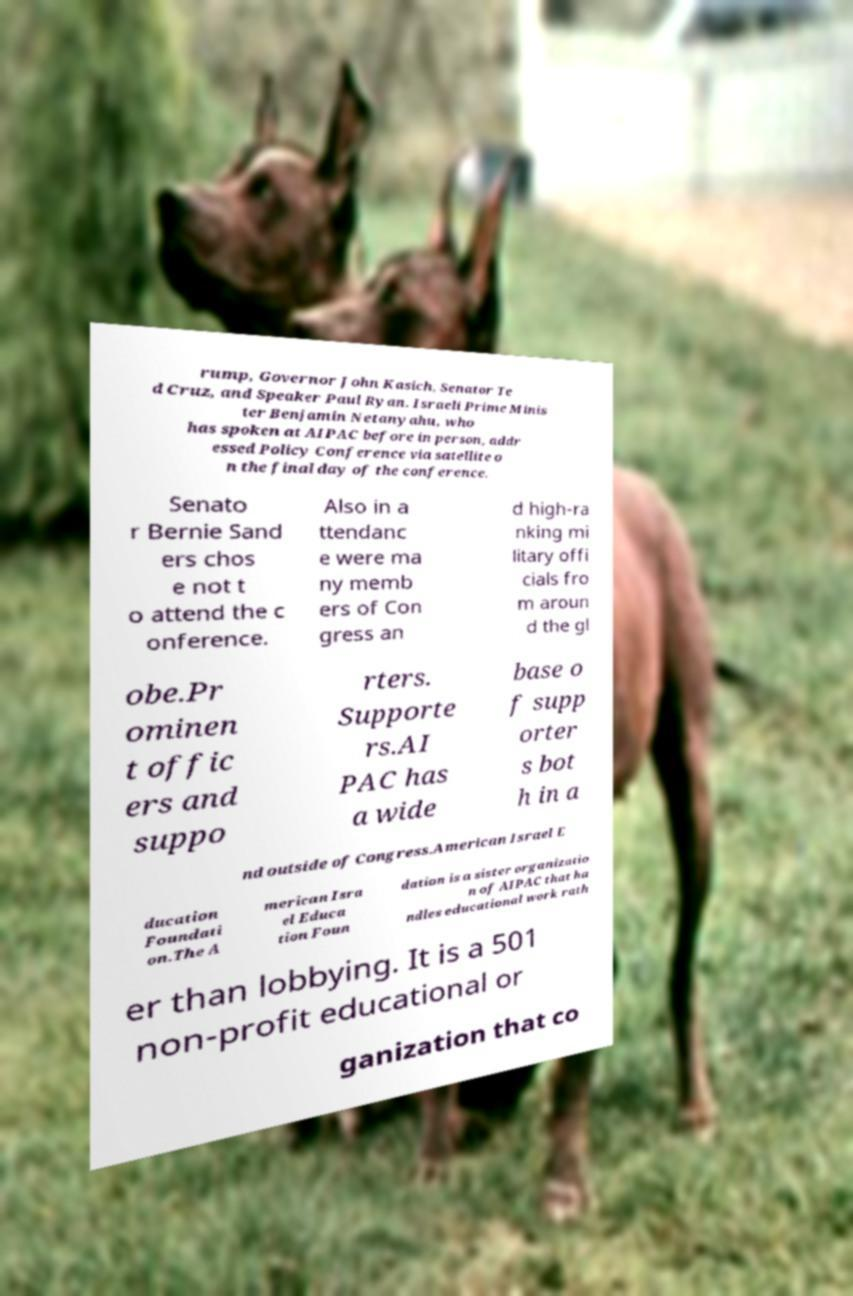I need the written content from this picture converted into text. Can you do that? rump, Governor John Kasich, Senator Te d Cruz, and Speaker Paul Ryan. Israeli Prime Minis ter Benjamin Netanyahu, who has spoken at AIPAC before in person, addr essed Policy Conference via satellite o n the final day of the conference. Senato r Bernie Sand ers chos e not t o attend the c onference. Also in a ttendanc e were ma ny memb ers of Con gress an d high-ra nking mi litary offi cials fro m aroun d the gl obe.Pr ominen t offic ers and suppo rters. Supporte rs.AI PAC has a wide base o f supp orter s bot h in a nd outside of Congress.American Israel E ducation Foundati on.The A merican Isra el Educa tion Foun dation is a sister organizatio n of AIPAC that ha ndles educational work rath er than lobbying. It is a 501 non-profit educational or ganization that co 